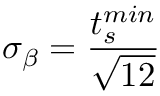Convert formula to latex. <formula><loc_0><loc_0><loc_500><loc_500>\sigma _ { \beta } = \frac { t _ { s } ^ { \min } } { \sqrt { 1 2 } }</formula> 